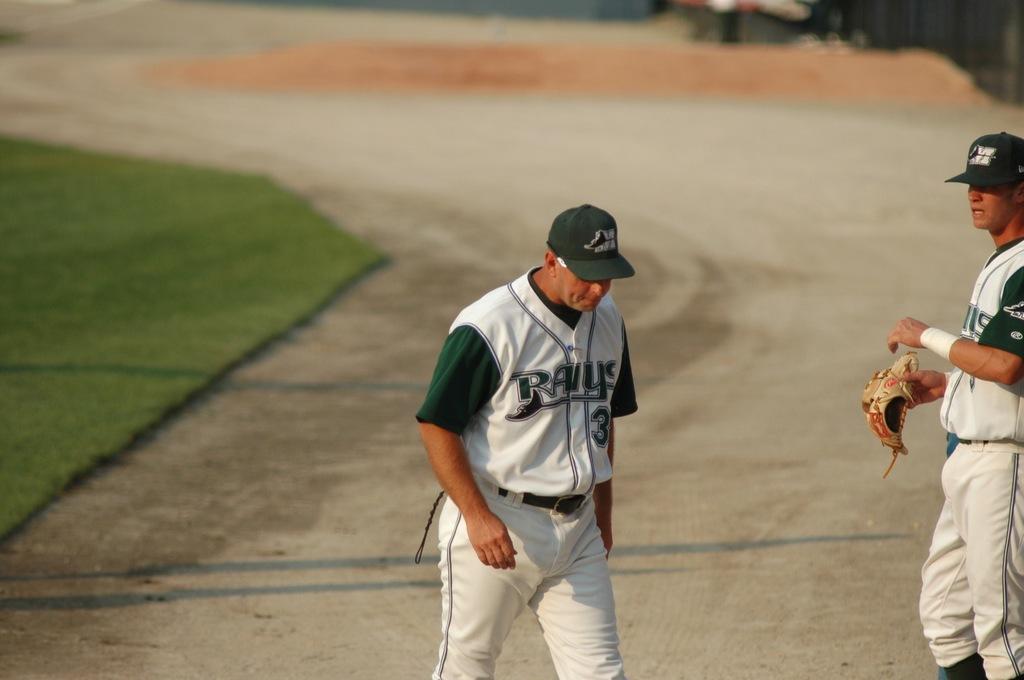What team name is on the player's jersey?
Provide a succinct answer. Rays. What number is on the jersey on the left?
Your response must be concise. 3. 